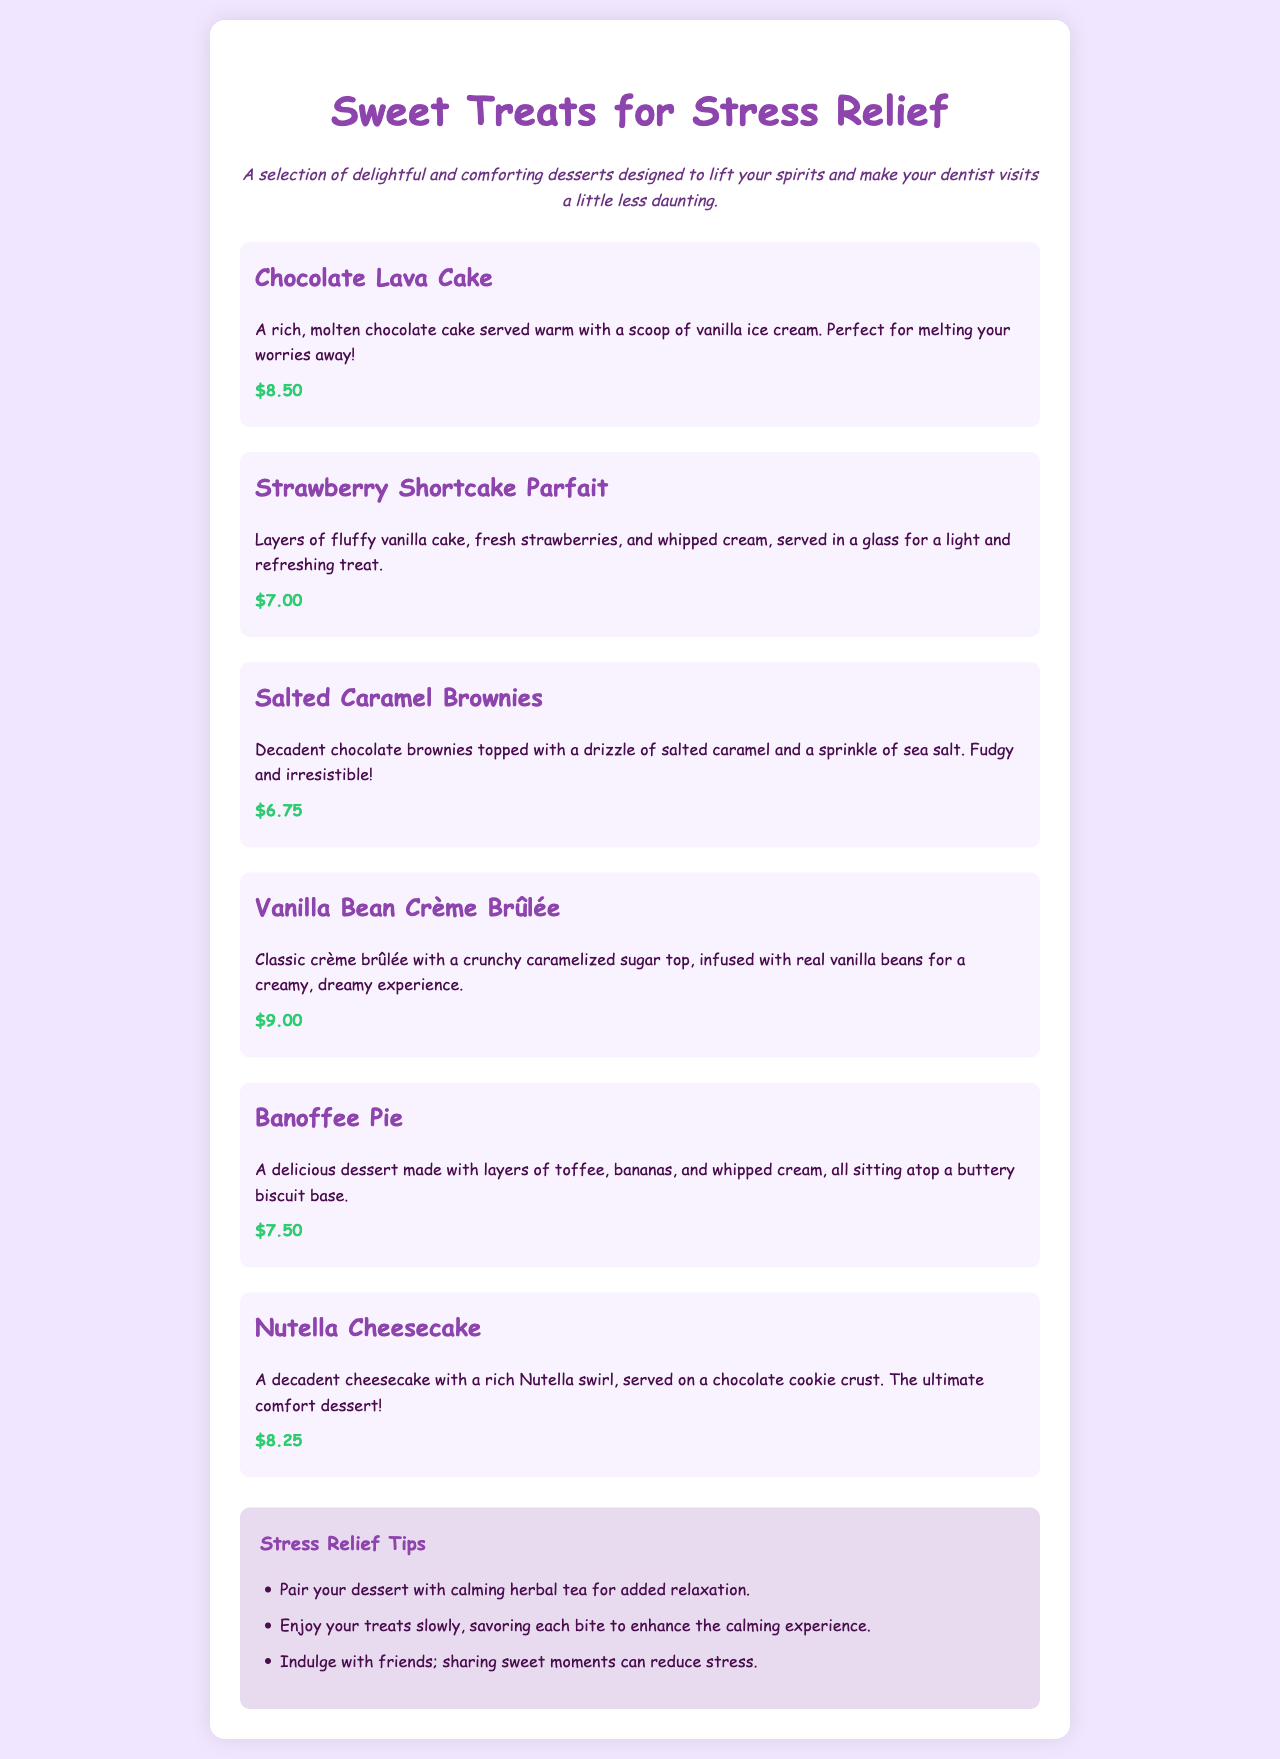What is the price of the Chocolate Lava Cake? The price is specifically stated in the menu for the Chocolate Lava Cake.
Answer: $8.50 What dessert is served in a glass? The menu lists a dessert served in a glass, which indicates it is likely light and refreshing.
Answer: Strawberry Shortcake Parfait Which dessert has Nutella? The document mentions a dessert that features Nutella prominently in its description.
Answer: Nutella Cheesecake How many tips for stress relief are provided? The menu includes a specific section for stress relief tips, and the number is stated clearly.
Answer: Three What type of cake is the Salted Caramel Brownie described as? The description in the menu clearly defines the texture and quality of the Salted Caramel Brownie.
Answer: Fudgy What is the color scheme of the document? The colors used in the document relate directly to the design described in the styling section.
Answer: Purple and white 